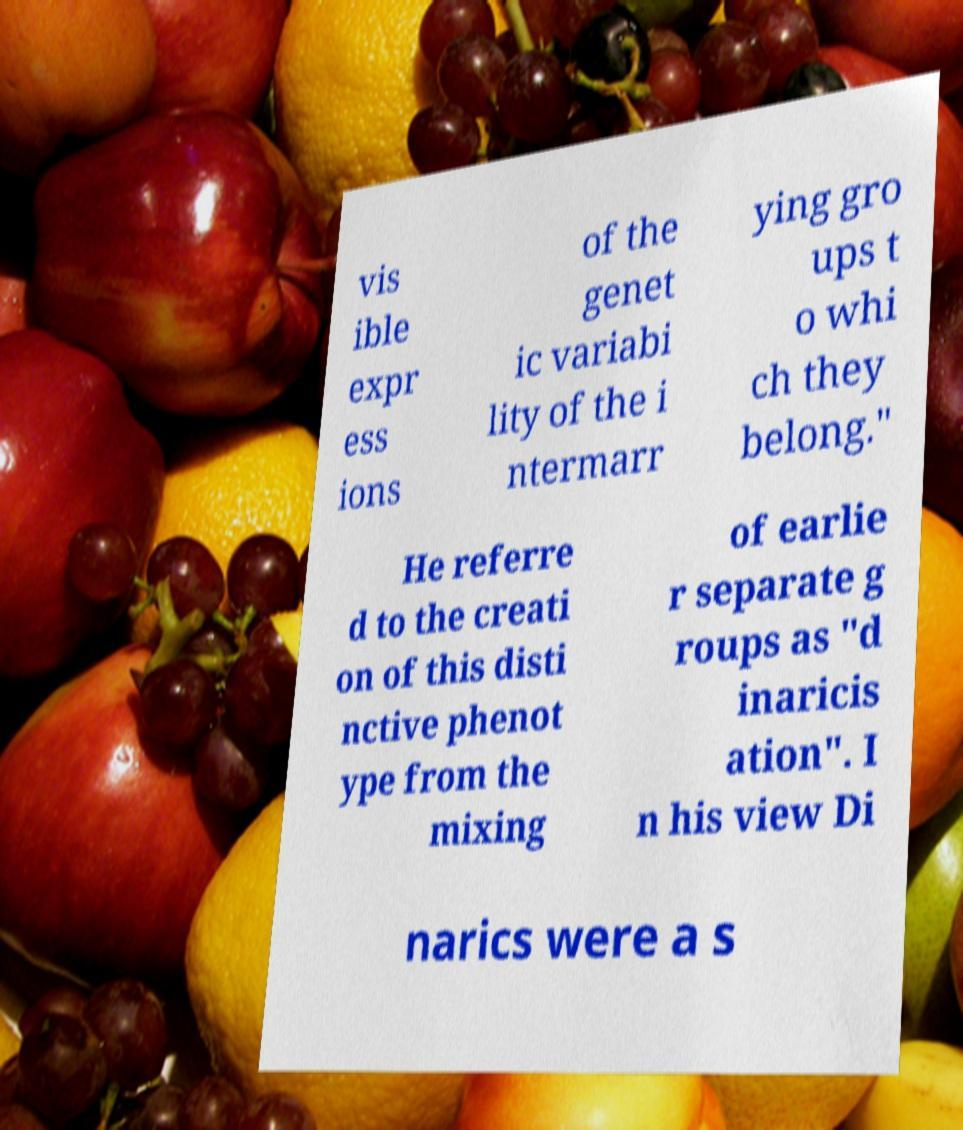I need the written content from this picture converted into text. Can you do that? vis ible expr ess ions of the genet ic variabi lity of the i ntermarr ying gro ups t o whi ch they belong." He referre d to the creati on of this disti nctive phenot ype from the mixing of earlie r separate g roups as "d inaricis ation". I n his view Di narics were a s 